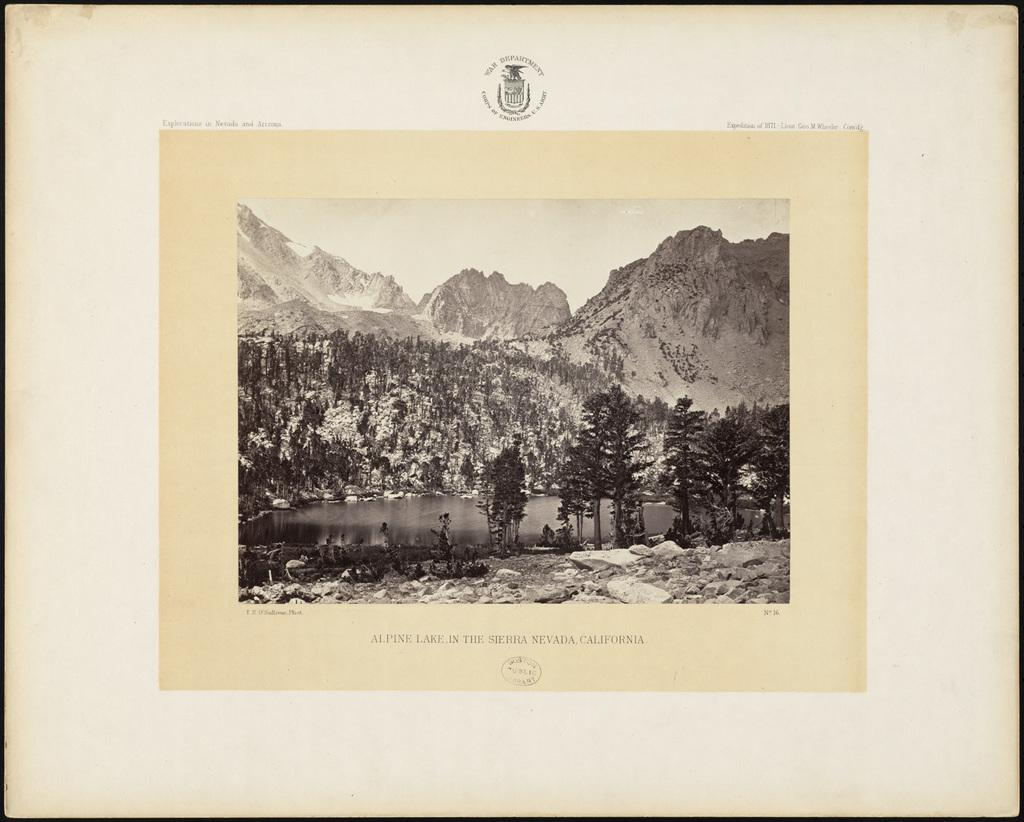What type of natural features can be seen in the image? There are trees, mountains, and a river visible in the image. What part of the natural environment is visible in the image? The sky is visible in the image. Can you describe the landscape in the image? The image features a landscape with trees, mountains, a river, and the sky. What type of houses can be seen in the image? There are no houses present in the image; it features a landscape with trees, mountains, a river, and the sky. What is the main attraction in the image? The image does not depict a specific attraction; it shows a natural landscape with trees, mountains, a river, and the sky. 